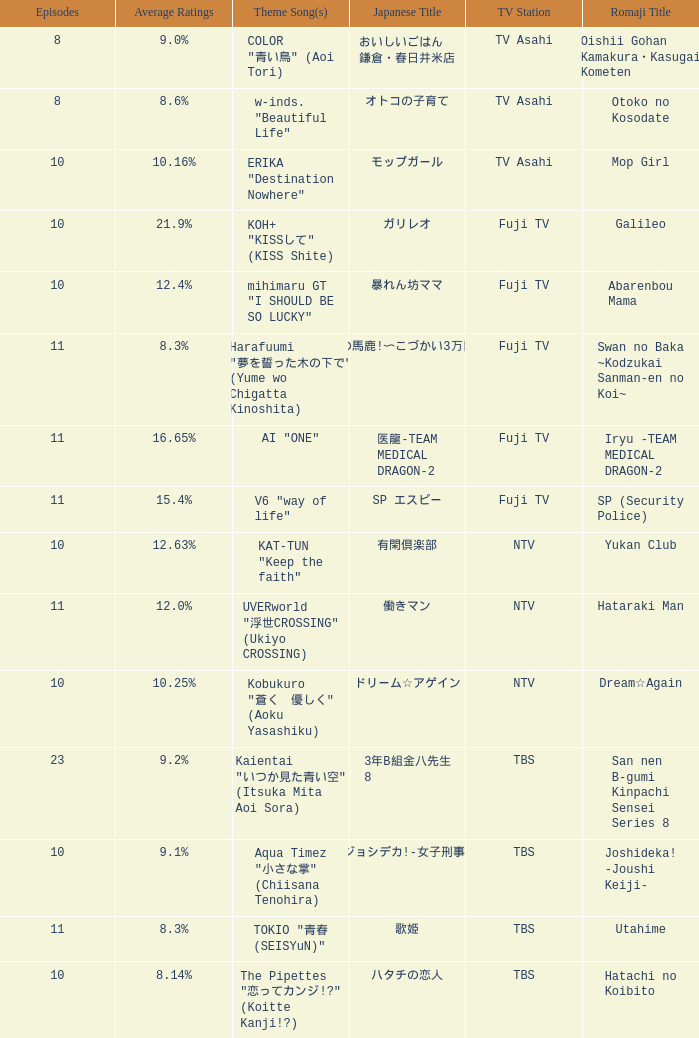What is the main theme song for 働きマン? UVERworld "浮世CROSSING" (Ukiyo CROSSING). Could you parse the entire table as a dict? {'header': ['Episodes', 'Average Ratings', 'Theme Song(s)', 'Japanese Title', 'TV Station', 'Romaji Title'], 'rows': [['8', '9.0%', 'COLOR "青い鳥" (Aoi Tori)', 'おいしいごはん 鎌倉・春日井米店', 'TV Asahi', 'Oishii Gohan Kamakura・Kasugai Kometen'], ['8', '8.6%', 'w-inds. "Beautiful Life"', 'オトコの子育て', 'TV Asahi', 'Otoko no Kosodate'], ['10', '10.16%', 'ERIKA "Destination Nowhere"', 'モップガール', 'TV Asahi', 'Mop Girl'], ['10', '21.9%', 'KOH+ "KISSして" (KISS Shite)', 'ガリレオ', 'Fuji TV', 'Galileo'], ['10', '12.4%', 'mihimaru GT "I SHOULD BE SO LUCKY"', '暴れん坊ママ', 'Fuji TV', 'Abarenbou Mama'], ['11', '8.3%', 'Harafuumi "夢を誓った木の下で" (Yume wo Chigatta Kinoshita)', 'スワンの馬鹿!〜こづかい3万円の恋〜', 'Fuji TV', 'Swan no Baka ~Kodzukai Sanman-en no Koi~'], ['11', '16.65%', 'AI "ONE"', '医龍-TEAM MEDICAL DRAGON-2', 'Fuji TV', 'Iryu -TEAM MEDICAL DRAGON-2'], ['11', '15.4%', 'V6 "way of life"', 'SP エスピー', 'Fuji TV', 'SP (Security Police)'], ['10', '12.63%', 'KAT-TUN "Keep the faith"', '有閑倶楽部', 'NTV', 'Yukan Club'], ['11', '12.0%', 'UVERworld "浮世CROSSING" (Ukiyo CROSSING)', '働きマン', 'NTV', 'Hataraki Man'], ['10', '10.25%', 'Kobukuro "蒼く\u3000優しく" (Aoku Yasashiku)', 'ドリーム☆アゲイン', 'NTV', 'Dream☆Again'], ['23', '9.2%', 'Kaientai "いつか見た青い空" (Itsuka Mita Aoi Sora)', '3年B組金八先生 8', 'TBS', 'San nen B-gumi Kinpachi Sensei Series 8'], ['10', '9.1%', 'Aqua Timez "小さな掌" (Chiisana Tenohira)', 'ジョシデカ!-女子刑事-', 'TBS', 'Joshideka! -Joushi Keiji-'], ['11', '8.3%', 'TOKIO "青春 (SEISYuN)"', '歌姫', 'TBS', 'Utahime'], ['10', '8.14%', 'The Pipettes "恋ってカンジ!?" (Koitte Kanji!?)', 'ハタチの恋人', 'TBS', 'Hatachi no Koibito']]} 